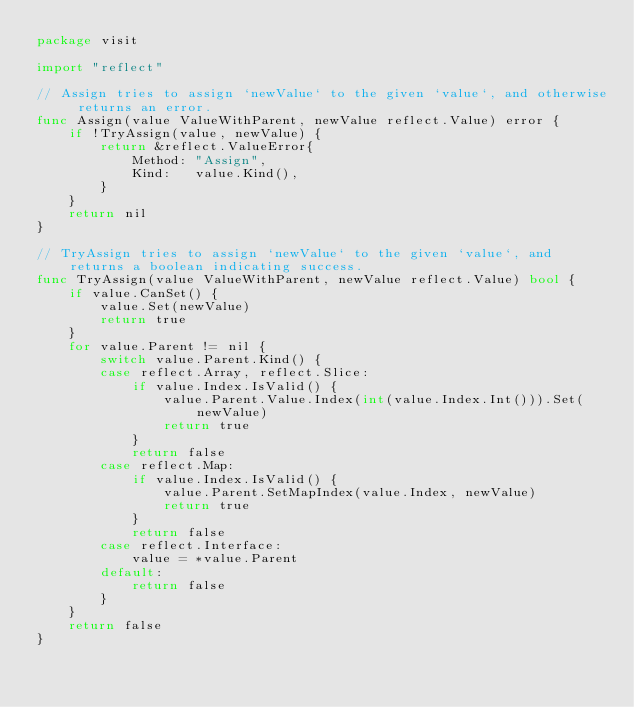Convert code to text. <code><loc_0><loc_0><loc_500><loc_500><_Go_>package visit

import "reflect"

// Assign tries to assign `newValue` to the given `value`, and otherwise returns an error.
func Assign(value ValueWithParent, newValue reflect.Value) error {
	if !TryAssign(value, newValue) {
		return &reflect.ValueError{
			Method: "Assign",
			Kind:   value.Kind(),
		}
	}
	return nil
}

// TryAssign tries to assign `newValue` to the given `value`, and returns a boolean indicating success.
func TryAssign(value ValueWithParent, newValue reflect.Value) bool {
	if value.CanSet() {
		value.Set(newValue)
		return true
	}
	for value.Parent != nil {
		switch value.Parent.Kind() {
		case reflect.Array, reflect.Slice:
			if value.Index.IsValid() {
				value.Parent.Value.Index(int(value.Index.Int())).Set(newValue)
				return true
			}
			return false
		case reflect.Map:
			if value.Index.IsValid() {
				value.Parent.SetMapIndex(value.Index, newValue)
				return true
			}
			return false
		case reflect.Interface:
			value = *value.Parent
		default:
			return false
		}
	}
	return false
}
</code> 